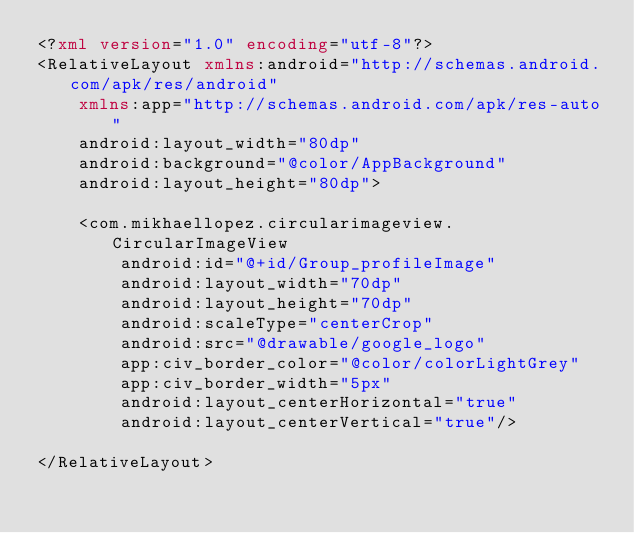Convert code to text. <code><loc_0><loc_0><loc_500><loc_500><_XML_><?xml version="1.0" encoding="utf-8"?>
<RelativeLayout xmlns:android="http://schemas.android.com/apk/res/android"
    xmlns:app="http://schemas.android.com/apk/res-auto"
    android:layout_width="80dp"
    android:background="@color/AppBackground"
    android:layout_height="80dp">

    <com.mikhaellopez.circularimageview.CircularImageView
        android:id="@+id/Group_profileImage"
        android:layout_width="70dp"
        android:layout_height="70dp"
        android:scaleType="centerCrop"
        android:src="@drawable/google_logo"
        app:civ_border_color="@color/colorLightGrey"
        app:civ_border_width="5px"
        android:layout_centerHorizontal="true"
        android:layout_centerVertical="true"/>

</RelativeLayout></code> 